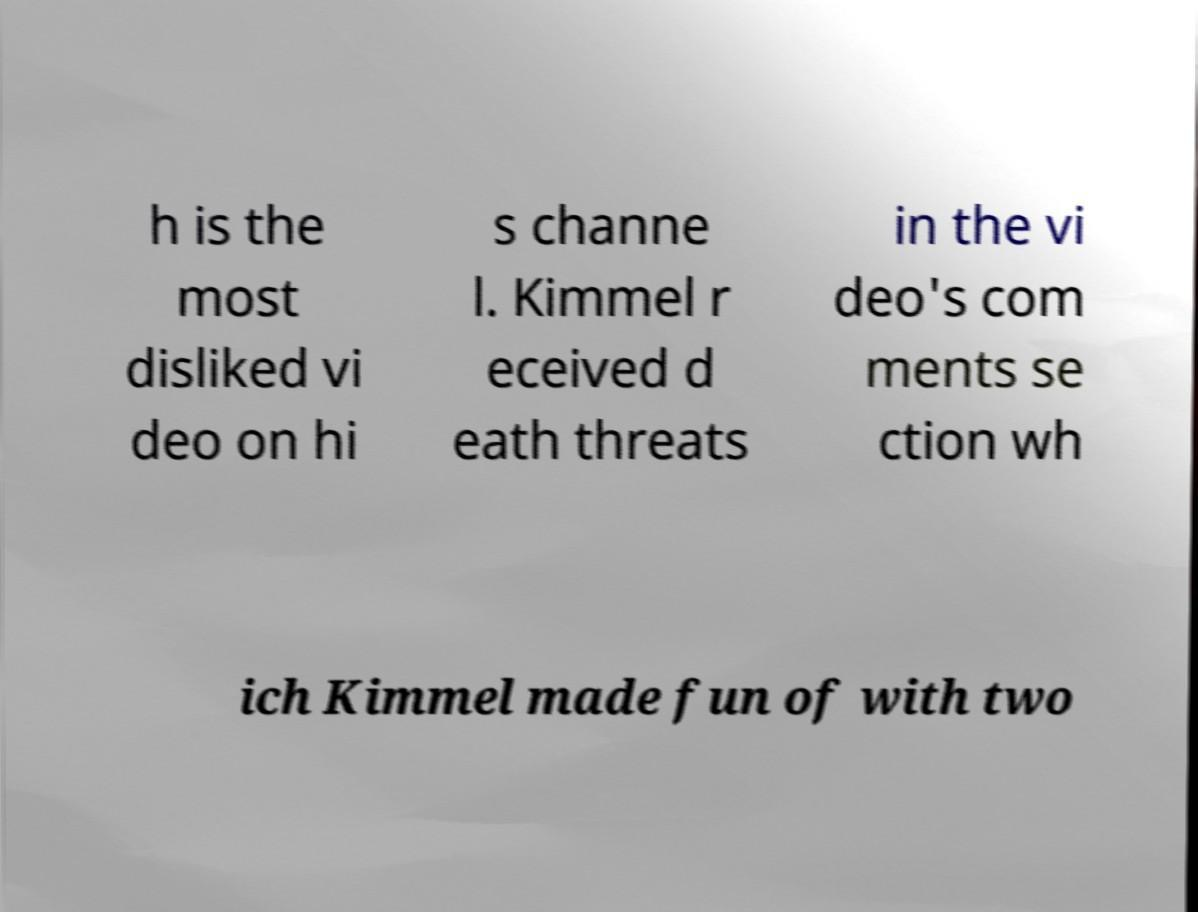I need the written content from this picture converted into text. Can you do that? h is the most disliked vi deo on hi s channe l. Kimmel r eceived d eath threats in the vi deo's com ments se ction wh ich Kimmel made fun of with two 